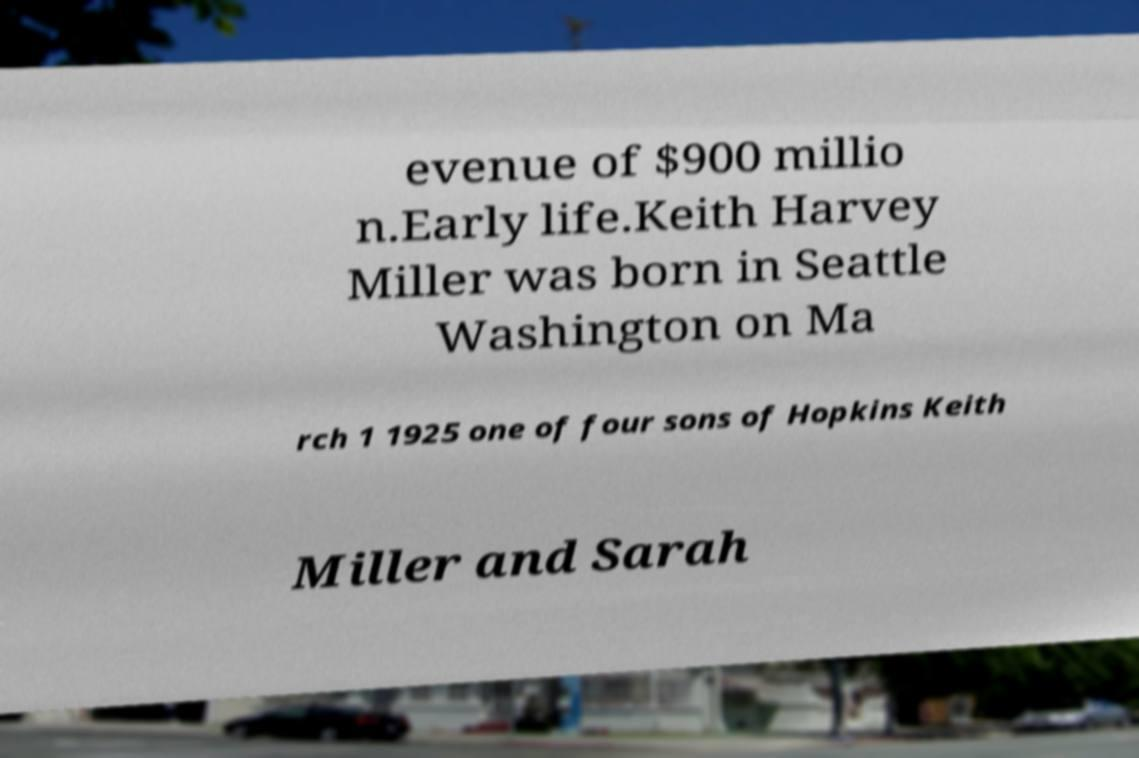Please read and relay the text visible in this image. What does it say? evenue of $900 millio n.Early life.Keith Harvey Miller was born in Seattle Washington on Ma rch 1 1925 one of four sons of Hopkins Keith Miller and Sarah 